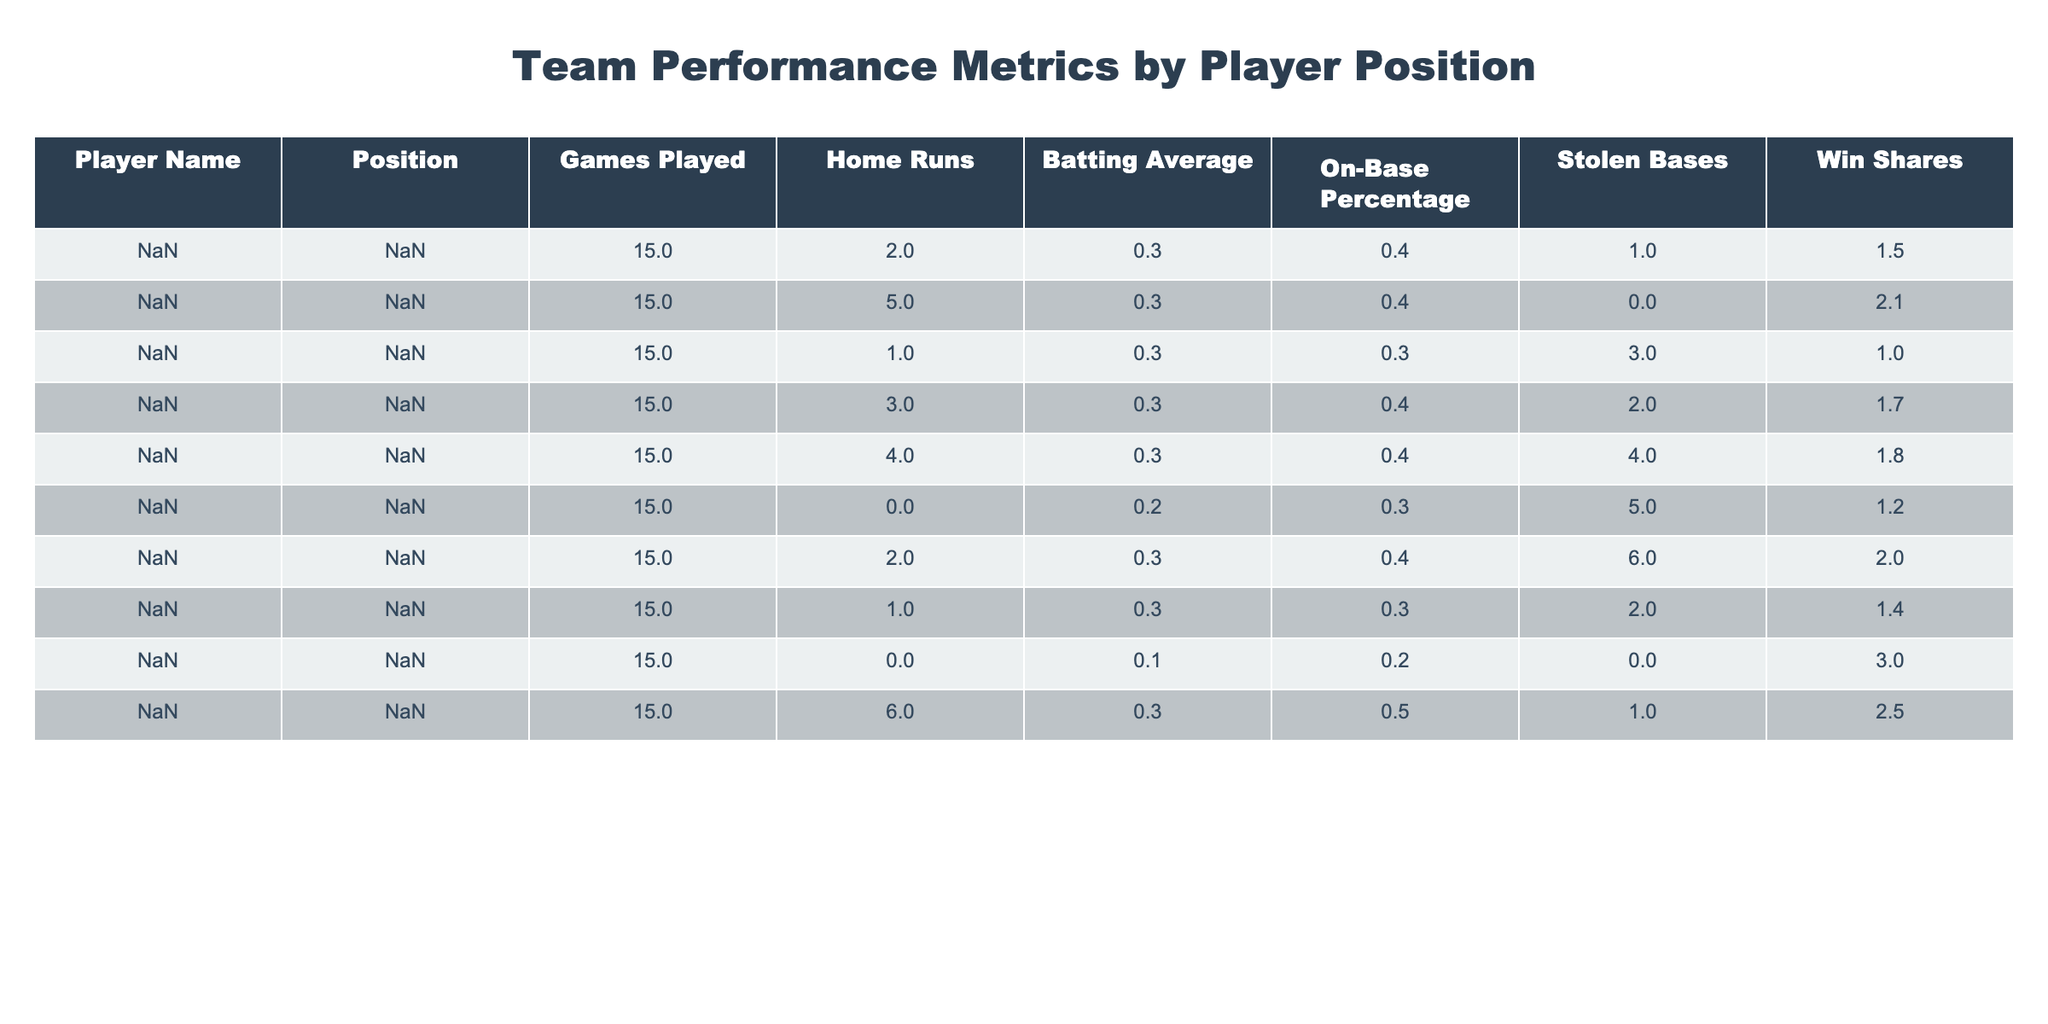What is the batting average of Sophia Thomas? The table shows that the batting average of Sophia Thomas, who plays as the Designated Hitter, is 0.320.
Answer: 0.320 Who has the highest number of stolen bases? Looking at the table, we can see that Liam Martinez has the highest number of stolen bases at 6.
Answer: Liam Martinez What is the total number of home runs scored by the infield players? The infield players are John Smith (2), Martin Johnson (5), Emily Davis (1), Chris Brown (3), and Sarah Wilson (4). Adding these up gives 2 + 5 + 1 + 3 + 4 = 15 home runs.
Answer: 15 Is there a player with a batting average lower than 0.250? By checking the table, we can see Noah Anderson has a batting average of 0.100, which is indeed lower than 0.250.
Answer: Yes Which position has the lowest On-Base Percentage? The On-Base Percentages for each player are: John Smith (0.360), Martin Johnson (0.400), Emily Davis (0.340), Chris Brown (0.370), Sarah Wilson (0.360), Jake Garcia (0.330), Liam Martinez (0.380), Olivia Taylor (0.340), Noah Anderson (0.200), Sophia Thomas (0.450). The lowest is Noah Anderson at 0.200.
Answer: Noah Anderson What is the average number of Win Shares for players in the outfield? The outfield players are Jake Garcia (1.2), Liam Martinez (2.0), and Olivia Taylor (1.4). To find the average, we add them: 1.2 + 2.0 + 1.4 = 4.6, then divide by 3, which is 4.6 / 3 = 1.53.
Answer: 1.53 Which player had a higher average, Martin Johnson or Chris Brown? Martin Johnson has a batting average of 0.310, while Chris Brown has a batting average of 0.290. Comparing them shows Martin Johnson has the higher batting average.
Answer: Martin Johnson How many players have at least 2 home runs? We check each player’s home runs: John Smith (2), Martin Johnson (5), Chris Brown (3), Sarah Wilson (4), and Sophia Thomas (6). Counting these, we find there are 5 players with at least 2 home runs.
Answer: 5 Is it true that the Pitcher has a Win Share greater than 2? The table displays Noah Anderson, the Pitcher, with a Win Share of 3.0, which is indeed greater than 2.
Answer: Yes What is the total number of games played by the team? All players have played 15 games each, and there are 10 players. Therefore, the total number of games played is 15 x 10 = 150.
Answer: 150 